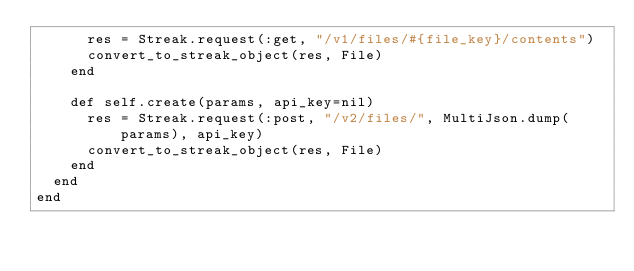<code> <loc_0><loc_0><loc_500><loc_500><_Ruby_>      res = Streak.request(:get, "/v1/files/#{file_key}/contents")
      convert_to_streak_object(res, File)
    end

    def self.create(params, api_key=nil)
      res = Streak.request(:post, "/v2/files/", MultiJson.dump(params), api_key)
      convert_to_streak_object(res, File)
    end
  end
end
</code> 